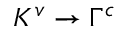<formula> <loc_0><loc_0><loc_500><loc_500>K ^ { v } \rightarrow \Gamma ^ { c }</formula> 